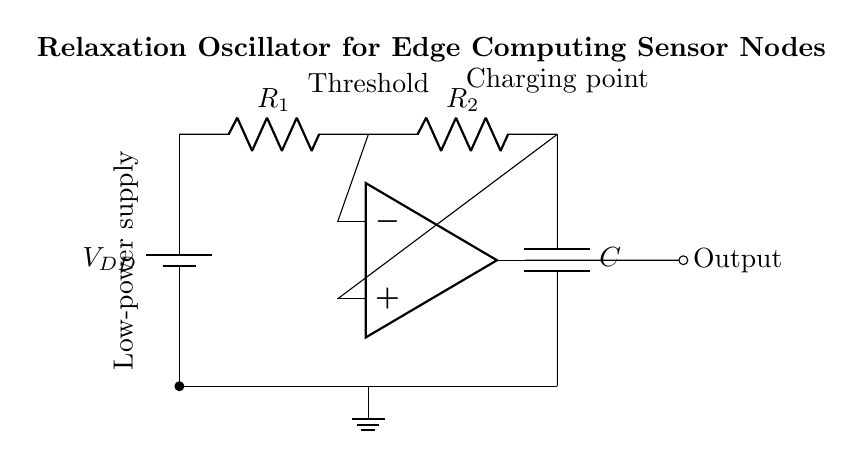What is the component type used for generating a square wave? The comparator in the circuit serves the purpose of generating the square wave signal by comparing two voltage levels, thus switching its output between high and low states.
Answer: Comparator What is the value of the supply voltage in this circuit? The circuit diagram indicates the supply voltage as V subscript DD, commonly representing a positive voltage supply, typical for this type of circuit.
Answer: VDD Which components are responsible for charging the capacitor? The resistors R1 and R2 work together in the charging process by creating a time constant that determines how quickly the capacitor charges up to the threshold voltage.
Answer: R1, R2 What does the label "Threshold" signify in the diagram? The "Threshold" label indicates the voltage level at which the comparator switches its output state, triggering the discharge of the capacitor to create oscillation.
Answer: Voltage level What is the role of the capacitor in this oscillator circuit? The capacitor stores energy and provides the necessary time delay by charging and discharging, which is critical for producing oscillations at the output.
Answer: Energy storage Where does the output of the oscillator circuit go? The output of the comparator is directed to the output node on the right side, which can be connected to other components or systems for further processing.
Answer: Output node 